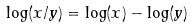<formula> <loc_0><loc_0><loc_500><loc_500>\log ( x / y ) = \log ( x ) - \log ( y )</formula> 